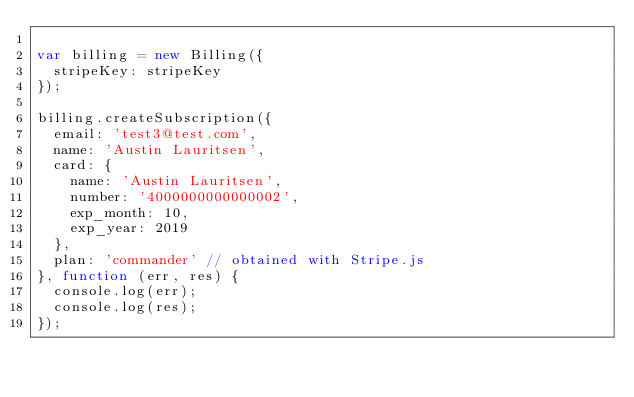<code> <loc_0><loc_0><loc_500><loc_500><_JavaScript_>
var billing = new Billing({
  stripeKey: stripeKey
});

billing.createSubscription({
  email: 'test3@test.com',
  name: 'Austin Lauritsen',
  card: {
    name: 'Austin Lauritsen',
    number: '4000000000000002',
    exp_month: 10,
    exp_year: 2019
  },
  plan: 'commander' // obtained with Stripe.js
}, function (err, res) {
  console.log(err);
  console.log(res);
});</code> 